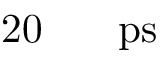<formula> <loc_0><loc_0><loc_500><loc_500>2 0 { { \, } } { p s }</formula> 